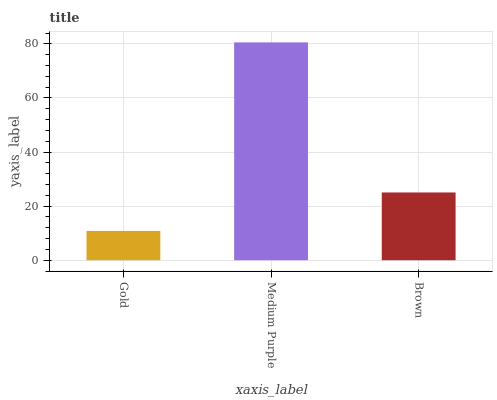Is Gold the minimum?
Answer yes or no. Yes. Is Medium Purple the maximum?
Answer yes or no. Yes. Is Brown the minimum?
Answer yes or no. No. Is Brown the maximum?
Answer yes or no. No. Is Medium Purple greater than Brown?
Answer yes or no. Yes. Is Brown less than Medium Purple?
Answer yes or no. Yes. Is Brown greater than Medium Purple?
Answer yes or no. No. Is Medium Purple less than Brown?
Answer yes or no. No. Is Brown the high median?
Answer yes or no. Yes. Is Brown the low median?
Answer yes or no. Yes. Is Gold the high median?
Answer yes or no. No. Is Medium Purple the low median?
Answer yes or no. No. 